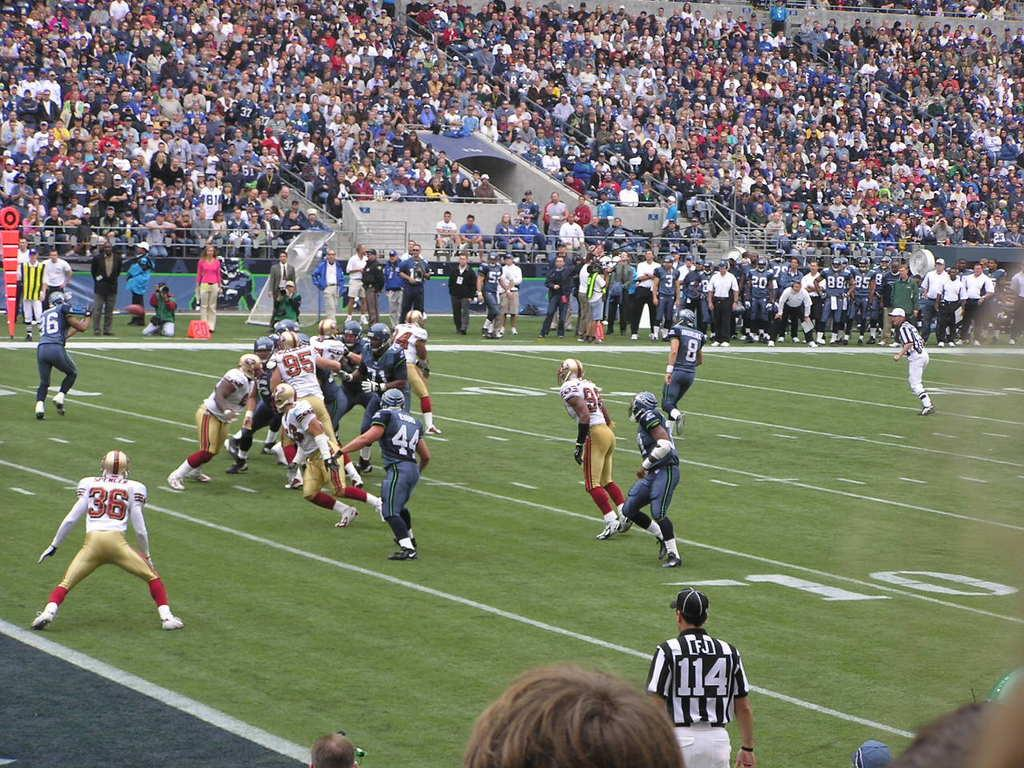What activity are the people in the image engaged in? The people in the image are playing a match. Where is the match taking place? The match is taking place on a ground. Are there any observers present during the match? Yes, there are spectators watching the match. How many jellyfish can be seen swimming in the background of the image? There are no jellyfish present in the image; it features people playing a match on a ground with spectators watching. 